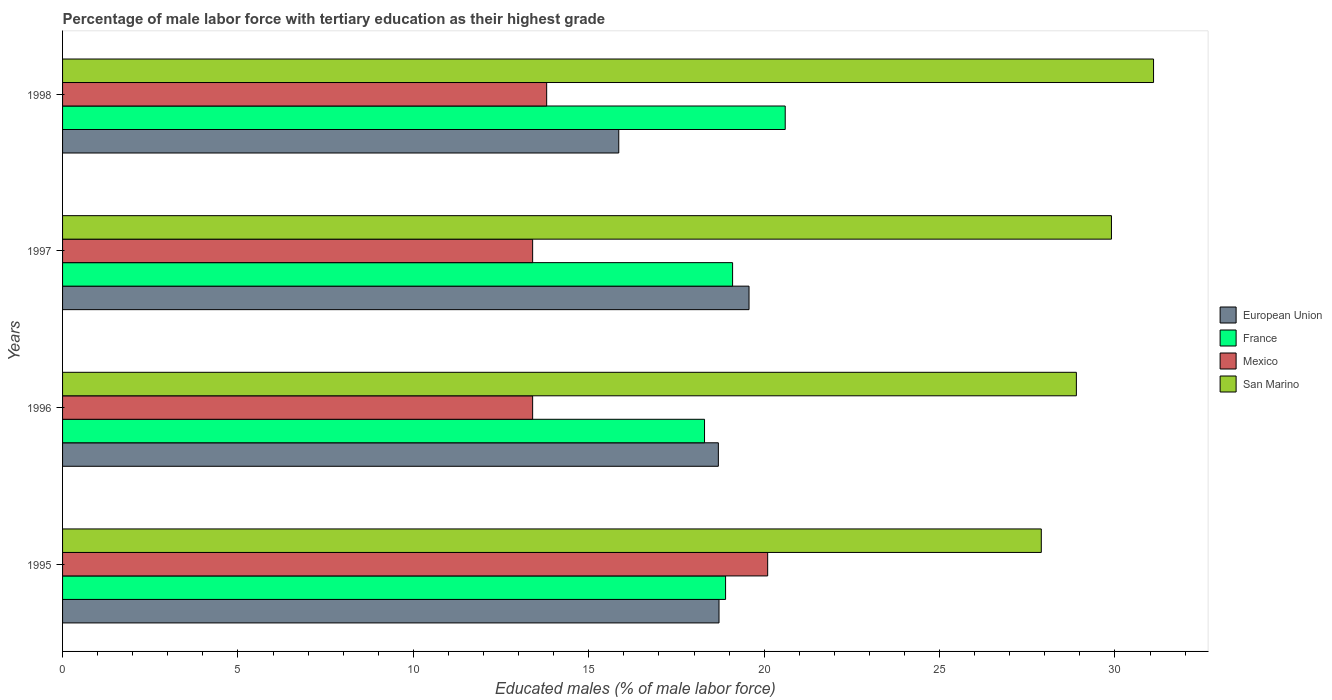How many groups of bars are there?
Give a very brief answer. 4. How many bars are there on the 2nd tick from the top?
Your response must be concise. 4. How many bars are there on the 2nd tick from the bottom?
Your answer should be compact. 4. What is the label of the 3rd group of bars from the top?
Your answer should be compact. 1996. What is the percentage of male labor force with tertiary education in European Union in 1995?
Your response must be concise. 18.71. Across all years, what is the maximum percentage of male labor force with tertiary education in France?
Keep it short and to the point. 20.6. Across all years, what is the minimum percentage of male labor force with tertiary education in European Union?
Provide a succinct answer. 15.86. In which year was the percentage of male labor force with tertiary education in European Union minimum?
Make the answer very short. 1998. What is the total percentage of male labor force with tertiary education in France in the graph?
Provide a short and direct response. 76.9. What is the difference between the percentage of male labor force with tertiary education in Mexico in 1995 and that in 1998?
Your response must be concise. 6.3. What is the difference between the percentage of male labor force with tertiary education in France in 1996 and the percentage of male labor force with tertiary education in Mexico in 1998?
Give a very brief answer. 4.5. What is the average percentage of male labor force with tertiary education in San Marino per year?
Keep it short and to the point. 29.45. In the year 1996, what is the difference between the percentage of male labor force with tertiary education in European Union and percentage of male labor force with tertiary education in San Marino?
Give a very brief answer. -10.21. In how many years, is the percentage of male labor force with tertiary education in European Union greater than 8 %?
Provide a succinct answer. 4. What is the ratio of the percentage of male labor force with tertiary education in San Marino in 1996 to that in 1998?
Provide a succinct answer. 0.93. Is the percentage of male labor force with tertiary education in San Marino in 1995 less than that in 1997?
Make the answer very short. Yes. Is the difference between the percentage of male labor force with tertiary education in European Union in 1995 and 1996 greater than the difference between the percentage of male labor force with tertiary education in San Marino in 1995 and 1996?
Keep it short and to the point. Yes. What is the difference between the highest and the second highest percentage of male labor force with tertiary education in European Union?
Your answer should be very brief. 0.86. What is the difference between the highest and the lowest percentage of male labor force with tertiary education in France?
Make the answer very short. 2.3. Is the sum of the percentage of male labor force with tertiary education in European Union in 1996 and 1997 greater than the maximum percentage of male labor force with tertiary education in San Marino across all years?
Offer a very short reply. Yes. Is it the case that in every year, the sum of the percentage of male labor force with tertiary education in Mexico and percentage of male labor force with tertiary education in France is greater than the sum of percentage of male labor force with tertiary education in San Marino and percentage of male labor force with tertiary education in European Union?
Provide a short and direct response. No. Is it the case that in every year, the sum of the percentage of male labor force with tertiary education in San Marino and percentage of male labor force with tertiary education in France is greater than the percentage of male labor force with tertiary education in European Union?
Give a very brief answer. Yes. How many bars are there?
Give a very brief answer. 16. Are all the bars in the graph horizontal?
Your response must be concise. Yes. How many years are there in the graph?
Make the answer very short. 4. Are the values on the major ticks of X-axis written in scientific E-notation?
Keep it short and to the point. No. Where does the legend appear in the graph?
Your answer should be compact. Center right. How are the legend labels stacked?
Keep it short and to the point. Vertical. What is the title of the graph?
Offer a terse response. Percentage of male labor force with tertiary education as their highest grade. What is the label or title of the X-axis?
Provide a short and direct response. Educated males (% of male labor force). What is the Educated males (% of male labor force) of European Union in 1995?
Provide a succinct answer. 18.71. What is the Educated males (% of male labor force) of France in 1995?
Make the answer very short. 18.9. What is the Educated males (% of male labor force) of Mexico in 1995?
Your response must be concise. 20.1. What is the Educated males (% of male labor force) in San Marino in 1995?
Keep it short and to the point. 27.9. What is the Educated males (% of male labor force) in European Union in 1996?
Ensure brevity in your answer.  18.69. What is the Educated males (% of male labor force) in France in 1996?
Provide a short and direct response. 18.3. What is the Educated males (% of male labor force) of Mexico in 1996?
Give a very brief answer. 13.4. What is the Educated males (% of male labor force) of San Marino in 1996?
Your answer should be very brief. 28.9. What is the Educated males (% of male labor force) in European Union in 1997?
Your answer should be very brief. 19.57. What is the Educated males (% of male labor force) of France in 1997?
Provide a short and direct response. 19.1. What is the Educated males (% of male labor force) of Mexico in 1997?
Keep it short and to the point. 13.4. What is the Educated males (% of male labor force) of San Marino in 1997?
Provide a short and direct response. 29.9. What is the Educated males (% of male labor force) in European Union in 1998?
Keep it short and to the point. 15.86. What is the Educated males (% of male labor force) in France in 1998?
Ensure brevity in your answer.  20.6. What is the Educated males (% of male labor force) of Mexico in 1998?
Ensure brevity in your answer.  13.8. What is the Educated males (% of male labor force) of San Marino in 1998?
Give a very brief answer. 31.1. Across all years, what is the maximum Educated males (% of male labor force) in European Union?
Ensure brevity in your answer.  19.57. Across all years, what is the maximum Educated males (% of male labor force) of France?
Make the answer very short. 20.6. Across all years, what is the maximum Educated males (% of male labor force) in Mexico?
Offer a very short reply. 20.1. Across all years, what is the maximum Educated males (% of male labor force) of San Marino?
Your response must be concise. 31.1. Across all years, what is the minimum Educated males (% of male labor force) of European Union?
Offer a very short reply. 15.86. Across all years, what is the minimum Educated males (% of male labor force) of France?
Make the answer very short. 18.3. Across all years, what is the minimum Educated males (% of male labor force) of Mexico?
Your answer should be compact. 13.4. Across all years, what is the minimum Educated males (% of male labor force) of San Marino?
Provide a short and direct response. 27.9. What is the total Educated males (% of male labor force) of European Union in the graph?
Give a very brief answer. 72.83. What is the total Educated males (% of male labor force) in France in the graph?
Your answer should be very brief. 76.9. What is the total Educated males (% of male labor force) of Mexico in the graph?
Ensure brevity in your answer.  60.7. What is the total Educated males (% of male labor force) of San Marino in the graph?
Ensure brevity in your answer.  117.8. What is the difference between the Educated males (% of male labor force) of European Union in 1995 and that in 1996?
Your response must be concise. 0.02. What is the difference between the Educated males (% of male labor force) of France in 1995 and that in 1996?
Offer a terse response. 0.6. What is the difference between the Educated males (% of male labor force) of European Union in 1995 and that in 1997?
Your answer should be very brief. -0.86. What is the difference between the Educated males (% of male labor force) of France in 1995 and that in 1997?
Offer a terse response. -0.2. What is the difference between the Educated males (% of male labor force) in Mexico in 1995 and that in 1997?
Ensure brevity in your answer.  6.7. What is the difference between the Educated males (% of male labor force) of European Union in 1995 and that in 1998?
Your answer should be compact. 2.86. What is the difference between the Educated males (% of male labor force) in France in 1995 and that in 1998?
Your answer should be very brief. -1.7. What is the difference between the Educated males (% of male labor force) in Mexico in 1995 and that in 1998?
Offer a very short reply. 6.3. What is the difference between the Educated males (% of male labor force) in European Union in 1996 and that in 1997?
Ensure brevity in your answer.  -0.87. What is the difference between the Educated males (% of male labor force) in Mexico in 1996 and that in 1997?
Offer a terse response. 0. What is the difference between the Educated males (% of male labor force) of European Union in 1996 and that in 1998?
Make the answer very short. 2.84. What is the difference between the Educated males (% of male labor force) in San Marino in 1996 and that in 1998?
Offer a very short reply. -2.2. What is the difference between the Educated males (% of male labor force) of European Union in 1997 and that in 1998?
Provide a succinct answer. 3.71. What is the difference between the Educated males (% of male labor force) in France in 1997 and that in 1998?
Provide a short and direct response. -1.5. What is the difference between the Educated males (% of male labor force) of European Union in 1995 and the Educated males (% of male labor force) of France in 1996?
Provide a succinct answer. 0.41. What is the difference between the Educated males (% of male labor force) in European Union in 1995 and the Educated males (% of male labor force) in Mexico in 1996?
Your answer should be compact. 5.31. What is the difference between the Educated males (% of male labor force) of European Union in 1995 and the Educated males (% of male labor force) of San Marino in 1996?
Your answer should be compact. -10.19. What is the difference between the Educated males (% of male labor force) in France in 1995 and the Educated males (% of male labor force) in Mexico in 1996?
Provide a succinct answer. 5.5. What is the difference between the Educated males (% of male labor force) in European Union in 1995 and the Educated males (% of male labor force) in France in 1997?
Your response must be concise. -0.39. What is the difference between the Educated males (% of male labor force) of European Union in 1995 and the Educated males (% of male labor force) of Mexico in 1997?
Give a very brief answer. 5.31. What is the difference between the Educated males (% of male labor force) in European Union in 1995 and the Educated males (% of male labor force) in San Marino in 1997?
Your answer should be compact. -11.19. What is the difference between the Educated males (% of male labor force) in France in 1995 and the Educated males (% of male labor force) in San Marino in 1997?
Offer a terse response. -11. What is the difference between the Educated males (% of male labor force) of Mexico in 1995 and the Educated males (% of male labor force) of San Marino in 1997?
Provide a short and direct response. -9.8. What is the difference between the Educated males (% of male labor force) in European Union in 1995 and the Educated males (% of male labor force) in France in 1998?
Your response must be concise. -1.89. What is the difference between the Educated males (% of male labor force) in European Union in 1995 and the Educated males (% of male labor force) in Mexico in 1998?
Make the answer very short. 4.91. What is the difference between the Educated males (% of male labor force) of European Union in 1995 and the Educated males (% of male labor force) of San Marino in 1998?
Provide a short and direct response. -12.39. What is the difference between the Educated males (% of male labor force) in France in 1995 and the Educated males (% of male labor force) in Mexico in 1998?
Give a very brief answer. 5.1. What is the difference between the Educated males (% of male labor force) of France in 1995 and the Educated males (% of male labor force) of San Marino in 1998?
Your answer should be very brief. -12.2. What is the difference between the Educated males (% of male labor force) in Mexico in 1995 and the Educated males (% of male labor force) in San Marino in 1998?
Keep it short and to the point. -11. What is the difference between the Educated males (% of male labor force) of European Union in 1996 and the Educated males (% of male labor force) of France in 1997?
Ensure brevity in your answer.  -0.41. What is the difference between the Educated males (% of male labor force) in European Union in 1996 and the Educated males (% of male labor force) in Mexico in 1997?
Provide a succinct answer. 5.29. What is the difference between the Educated males (% of male labor force) of European Union in 1996 and the Educated males (% of male labor force) of San Marino in 1997?
Your response must be concise. -11.21. What is the difference between the Educated males (% of male labor force) in France in 1996 and the Educated males (% of male labor force) in San Marino in 1997?
Ensure brevity in your answer.  -11.6. What is the difference between the Educated males (% of male labor force) in Mexico in 1996 and the Educated males (% of male labor force) in San Marino in 1997?
Provide a succinct answer. -16.5. What is the difference between the Educated males (% of male labor force) of European Union in 1996 and the Educated males (% of male labor force) of France in 1998?
Provide a succinct answer. -1.91. What is the difference between the Educated males (% of male labor force) of European Union in 1996 and the Educated males (% of male labor force) of Mexico in 1998?
Keep it short and to the point. 4.89. What is the difference between the Educated males (% of male labor force) in European Union in 1996 and the Educated males (% of male labor force) in San Marino in 1998?
Give a very brief answer. -12.41. What is the difference between the Educated males (% of male labor force) in France in 1996 and the Educated males (% of male labor force) in Mexico in 1998?
Offer a terse response. 4.5. What is the difference between the Educated males (% of male labor force) of France in 1996 and the Educated males (% of male labor force) of San Marino in 1998?
Ensure brevity in your answer.  -12.8. What is the difference between the Educated males (% of male labor force) in Mexico in 1996 and the Educated males (% of male labor force) in San Marino in 1998?
Your response must be concise. -17.7. What is the difference between the Educated males (% of male labor force) in European Union in 1997 and the Educated males (% of male labor force) in France in 1998?
Offer a terse response. -1.03. What is the difference between the Educated males (% of male labor force) of European Union in 1997 and the Educated males (% of male labor force) of Mexico in 1998?
Your response must be concise. 5.77. What is the difference between the Educated males (% of male labor force) in European Union in 1997 and the Educated males (% of male labor force) in San Marino in 1998?
Your answer should be compact. -11.53. What is the difference between the Educated males (% of male labor force) in France in 1997 and the Educated males (% of male labor force) in Mexico in 1998?
Give a very brief answer. 5.3. What is the difference between the Educated males (% of male labor force) of Mexico in 1997 and the Educated males (% of male labor force) of San Marino in 1998?
Keep it short and to the point. -17.7. What is the average Educated males (% of male labor force) in European Union per year?
Offer a very short reply. 18.21. What is the average Educated males (% of male labor force) in France per year?
Your answer should be compact. 19.23. What is the average Educated males (% of male labor force) of Mexico per year?
Keep it short and to the point. 15.18. What is the average Educated males (% of male labor force) in San Marino per year?
Offer a terse response. 29.45. In the year 1995, what is the difference between the Educated males (% of male labor force) of European Union and Educated males (% of male labor force) of France?
Your response must be concise. -0.19. In the year 1995, what is the difference between the Educated males (% of male labor force) of European Union and Educated males (% of male labor force) of Mexico?
Keep it short and to the point. -1.39. In the year 1995, what is the difference between the Educated males (% of male labor force) in European Union and Educated males (% of male labor force) in San Marino?
Make the answer very short. -9.19. In the year 1995, what is the difference between the Educated males (% of male labor force) of France and Educated males (% of male labor force) of San Marino?
Give a very brief answer. -9. In the year 1996, what is the difference between the Educated males (% of male labor force) of European Union and Educated males (% of male labor force) of France?
Ensure brevity in your answer.  0.39. In the year 1996, what is the difference between the Educated males (% of male labor force) of European Union and Educated males (% of male labor force) of Mexico?
Make the answer very short. 5.29. In the year 1996, what is the difference between the Educated males (% of male labor force) of European Union and Educated males (% of male labor force) of San Marino?
Give a very brief answer. -10.21. In the year 1996, what is the difference between the Educated males (% of male labor force) in France and Educated males (% of male labor force) in San Marino?
Give a very brief answer. -10.6. In the year 1996, what is the difference between the Educated males (% of male labor force) in Mexico and Educated males (% of male labor force) in San Marino?
Keep it short and to the point. -15.5. In the year 1997, what is the difference between the Educated males (% of male labor force) of European Union and Educated males (% of male labor force) of France?
Your answer should be very brief. 0.47. In the year 1997, what is the difference between the Educated males (% of male labor force) in European Union and Educated males (% of male labor force) in Mexico?
Offer a very short reply. 6.17. In the year 1997, what is the difference between the Educated males (% of male labor force) in European Union and Educated males (% of male labor force) in San Marino?
Your answer should be very brief. -10.33. In the year 1997, what is the difference between the Educated males (% of male labor force) in Mexico and Educated males (% of male labor force) in San Marino?
Make the answer very short. -16.5. In the year 1998, what is the difference between the Educated males (% of male labor force) in European Union and Educated males (% of male labor force) in France?
Ensure brevity in your answer.  -4.75. In the year 1998, what is the difference between the Educated males (% of male labor force) of European Union and Educated males (% of male labor force) of Mexico?
Offer a very short reply. 2.06. In the year 1998, what is the difference between the Educated males (% of male labor force) of European Union and Educated males (% of male labor force) of San Marino?
Provide a short and direct response. -15.24. In the year 1998, what is the difference between the Educated males (% of male labor force) of France and Educated males (% of male labor force) of San Marino?
Offer a very short reply. -10.5. In the year 1998, what is the difference between the Educated males (% of male labor force) in Mexico and Educated males (% of male labor force) in San Marino?
Your answer should be compact. -17.3. What is the ratio of the Educated males (% of male labor force) of France in 1995 to that in 1996?
Offer a very short reply. 1.03. What is the ratio of the Educated males (% of male labor force) of Mexico in 1995 to that in 1996?
Ensure brevity in your answer.  1.5. What is the ratio of the Educated males (% of male labor force) in San Marino in 1995 to that in 1996?
Your response must be concise. 0.97. What is the ratio of the Educated males (% of male labor force) of European Union in 1995 to that in 1997?
Your answer should be very brief. 0.96. What is the ratio of the Educated males (% of male labor force) in Mexico in 1995 to that in 1997?
Offer a terse response. 1.5. What is the ratio of the Educated males (% of male labor force) of San Marino in 1995 to that in 1997?
Offer a very short reply. 0.93. What is the ratio of the Educated males (% of male labor force) in European Union in 1995 to that in 1998?
Offer a very short reply. 1.18. What is the ratio of the Educated males (% of male labor force) in France in 1995 to that in 1998?
Your response must be concise. 0.92. What is the ratio of the Educated males (% of male labor force) of Mexico in 1995 to that in 1998?
Your response must be concise. 1.46. What is the ratio of the Educated males (% of male labor force) in San Marino in 1995 to that in 1998?
Provide a short and direct response. 0.9. What is the ratio of the Educated males (% of male labor force) of European Union in 1996 to that in 1997?
Give a very brief answer. 0.96. What is the ratio of the Educated males (% of male labor force) in France in 1996 to that in 1997?
Your response must be concise. 0.96. What is the ratio of the Educated males (% of male labor force) in San Marino in 1996 to that in 1997?
Offer a very short reply. 0.97. What is the ratio of the Educated males (% of male labor force) in European Union in 1996 to that in 1998?
Provide a short and direct response. 1.18. What is the ratio of the Educated males (% of male labor force) of France in 1996 to that in 1998?
Give a very brief answer. 0.89. What is the ratio of the Educated males (% of male labor force) of San Marino in 1996 to that in 1998?
Offer a very short reply. 0.93. What is the ratio of the Educated males (% of male labor force) of European Union in 1997 to that in 1998?
Your answer should be very brief. 1.23. What is the ratio of the Educated males (% of male labor force) of France in 1997 to that in 1998?
Make the answer very short. 0.93. What is the ratio of the Educated males (% of male labor force) of San Marino in 1997 to that in 1998?
Your answer should be compact. 0.96. What is the difference between the highest and the second highest Educated males (% of male labor force) in European Union?
Ensure brevity in your answer.  0.86. What is the difference between the highest and the second highest Educated males (% of male labor force) of France?
Your response must be concise. 1.5. What is the difference between the highest and the second highest Educated males (% of male labor force) of San Marino?
Your answer should be compact. 1.2. What is the difference between the highest and the lowest Educated males (% of male labor force) of European Union?
Ensure brevity in your answer.  3.71. What is the difference between the highest and the lowest Educated males (% of male labor force) in Mexico?
Provide a short and direct response. 6.7. 